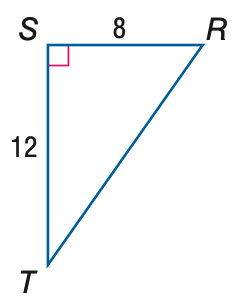Answer the mathemtical geometry problem and directly provide the correct option letter.
Question: Find the measure of \angle T to the nearest tenth.
Choices: A: 33.7 B: 41.8 C: 48.2 D: 56.3 A 